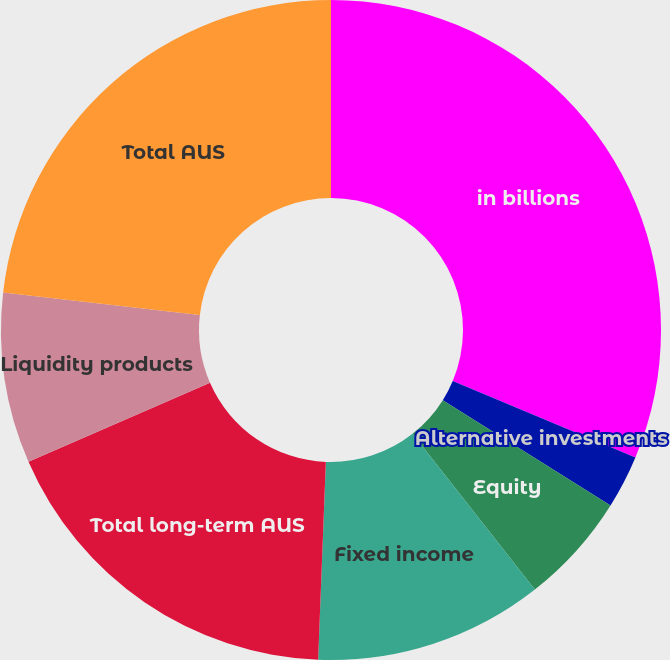<chart> <loc_0><loc_0><loc_500><loc_500><pie_chart><fcel>in billions<fcel>Alternative investments<fcel>Equity<fcel>Fixed income<fcel>Total long-term AUS<fcel>Liquidity products<fcel>Total AUS<nl><fcel>31.31%<fcel>2.61%<fcel>5.48%<fcel>11.22%<fcel>17.84%<fcel>8.35%<fcel>23.19%<nl></chart> 